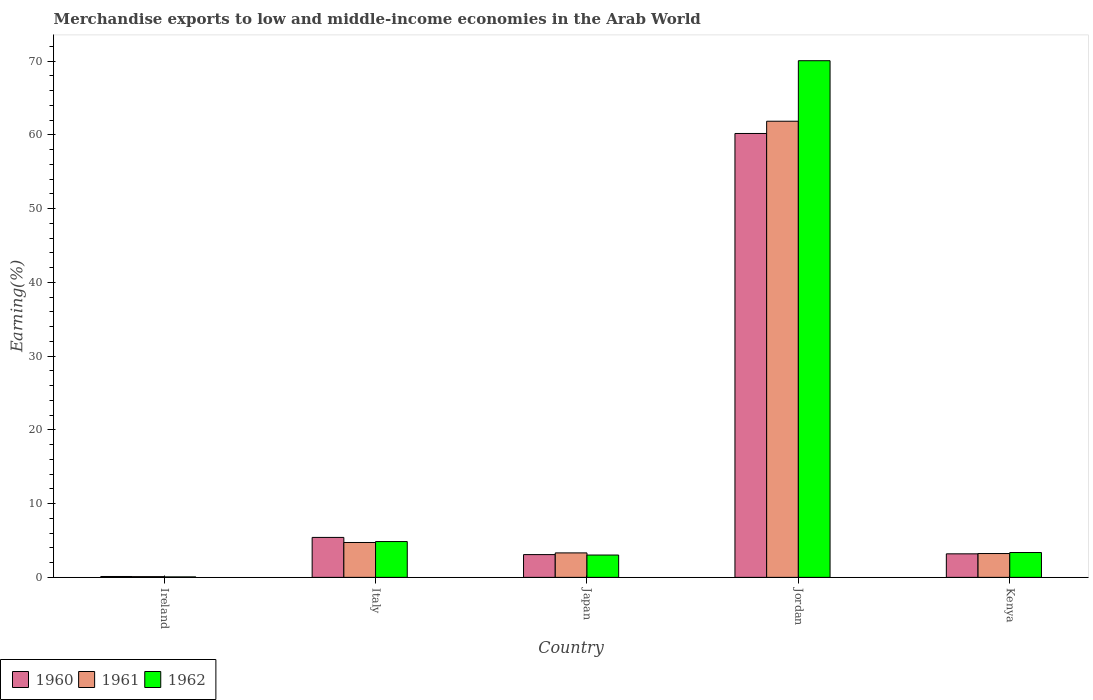How many bars are there on the 4th tick from the left?
Provide a succinct answer. 3. How many bars are there on the 5th tick from the right?
Provide a short and direct response. 3. What is the percentage of amount earned from merchandise exports in 1960 in Ireland?
Make the answer very short. 0.12. Across all countries, what is the maximum percentage of amount earned from merchandise exports in 1961?
Your response must be concise. 61.86. Across all countries, what is the minimum percentage of amount earned from merchandise exports in 1962?
Offer a very short reply. 0.06. In which country was the percentage of amount earned from merchandise exports in 1962 maximum?
Your answer should be compact. Jordan. In which country was the percentage of amount earned from merchandise exports in 1960 minimum?
Provide a short and direct response. Ireland. What is the total percentage of amount earned from merchandise exports in 1960 in the graph?
Your response must be concise. 72.02. What is the difference between the percentage of amount earned from merchandise exports in 1962 in Ireland and that in Kenya?
Offer a very short reply. -3.31. What is the difference between the percentage of amount earned from merchandise exports in 1961 in Kenya and the percentage of amount earned from merchandise exports in 1960 in Jordan?
Offer a very short reply. -56.97. What is the average percentage of amount earned from merchandise exports in 1960 per country?
Your response must be concise. 14.4. What is the difference between the percentage of amount earned from merchandise exports of/in 1962 and percentage of amount earned from merchandise exports of/in 1961 in Jordan?
Offer a very short reply. 8.21. What is the ratio of the percentage of amount earned from merchandise exports in 1962 in Ireland to that in Jordan?
Your response must be concise. 0. Is the percentage of amount earned from merchandise exports in 1960 in Italy less than that in Kenya?
Offer a terse response. No. Is the difference between the percentage of amount earned from merchandise exports in 1962 in Ireland and Kenya greater than the difference between the percentage of amount earned from merchandise exports in 1961 in Ireland and Kenya?
Offer a very short reply. No. What is the difference between the highest and the second highest percentage of amount earned from merchandise exports in 1960?
Give a very brief answer. -57.01. What is the difference between the highest and the lowest percentage of amount earned from merchandise exports in 1960?
Keep it short and to the point. 60.09. In how many countries, is the percentage of amount earned from merchandise exports in 1960 greater than the average percentage of amount earned from merchandise exports in 1960 taken over all countries?
Your answer should be compact. 1. What does the 1st bar from the left in Jordan represents?
Ensure brevity in your answer.  1960. What does the 3rd bar from the right in Italy represents?
Keep it short and to the point. 1960. How many countries are there in the graph?
Your response must be concise. 5. Are the values on the major ticks of Y-axis written in scientific E-notation?
Ensure brevity in your answer.  No. Does the graph contain grids?
Offer a very short reply. No. Where does the legend appear in the graph?
Your response must be concise. Bottom left. What is the title of the graph?
Your answer should be compact. Merchandise exports to low and middle-income economies in the Arab World. Does "1969" appear as one of the legend labels in the graph?
Provide a short and direct response. No. What is the label or title of the Y-axis?
Ensure brevity in your answer.  Earning(%). What is the Earning(%) of 1960 in Ireland?
Offer a very short reply. 0.12. What is the Earning(%) in 1961 in Ireland?
Your response must be concise. 0.1. What is the Earning(%) of 1962 in Ireland?
Provide a short and direct response. 0.06. What is the Earning(%) in 1960 in Italy?
Provide a succinct answer. 5.42. What is the Earning(%) of 1961 in Italy?
Offer a terse response. 4.73. What is the Earning(%) of 1962 in Italy?
Offer a very short reply. 4.86. What is the Earning(%) of 1960 in Japan?
Your response must be concise. 3.09. What is the Earning(%) of 1961 in Japan?
Your answer should be very brief. 3.32. What is the Earning(%) in 1962 in Japan?
Make the answer very short. 3.03. What is the Earning(%) of 1960 in Jordan?
Ensure brevity in your answer.  60.2. What is the Earning(%) in 1961 in Jordan?
Give a very brief answer. 61.86. What is the Earning(%) in 1962 in Jordan?
Keep it short and to the point. 70.07. What is the Earning(%) of 1960 in Kenya?
Keep it short and to the point. 3.19. What is the Earning(%) in 1961 in Kenya?
Offer a terse response. 3.23. What is the Earning(%) in 1962 in Kenya?
Give a very brief answer. 3.37. Across all countries, what is the maximum Earning(%) in 1960?
Keep it short and to the point. 60.2. Across all countries, what is the maximum Earning(%) in 1961?
Make the answer very short. 61.86. Across all countries, what is the maximum Earning(%) of 1962?
Your answer should be very brief. 70.07. Across all countries, what is the minimum Earning(%) of 1960?
Your response must be concise. 0.12. Across all countries, what is the minimum Earning(%) of 1961?
Your answer should be very brief. 0.1. Across all countries, what is the minimum Earning(%) in 1962?
Your answer should be compact. 0.06. What is the total Earning(%) in 1960 in the graph?
Your answer should be very brief. 72.02. What is the total Earning(%) in 1961 in the graph?
Offer a very short reply. 73.24. What is the total Earning(%) of 1962 in the graph?
Ensure brevity in your answer.  81.39. What is the difference between the Earning(%) in 1960 in Ireland and that in Italy?
Keep it short and to the point. -5.3. What is the difference between the Earning(%) in 1961 in Ireland and that in Italy?
Provide a succinct answer. -4.63. What is the difference between the Earning(%) of 1962 in Ireland and that in Italy?
Offer a terse response. -4.79. What is the difference between the Earning(%) in 1960 in Ireland and that in Japan?
Ensure brevity in your answer.  -2.97. What is the difference between the Earning(%) of 1961 in Ireland and that in Japan?
Your response must be concise. -3.22. What is the difference between the Earning(%) in 1962 in Ireland and that in Japan?
Make the answer very short. -2.97. What is the difference between the Earning(%) of 1960 in Ireland and that in Jordan?
Your response must be concise. -60.09. What is the difference between the Earning(%) in 1961 in Ireland and that in Jordan?
Make the answer very short. -61.77. What is the difference between the Earning(%) in 1962 in Ireland and that in Jordan?
Provide a succinct answer. -70.01. What is the difference between the Earning(%) in 1960 in Ireland and that in Kenya?
Offer a very short reply. -3.07. What is the difference between the Earning(%) in 1961 in Ireland and that in Kenya?
Your response must be concise. -3.13. What is the difference between the Earning(%) in 1962 in Ireland and that in Kenya?
Give a very brief answer. -3.31. What is the difference between the Earning(%) of 1960 in Italy and that in Japan?
Your answer should be very brief. 2.33. What is the difference between the Earning(%) of 1961 in Italy and that in Japan?
Give a very brief answer. 1.41. What is the difference between the Earning(%) in 1962 in Italy and that in Japan?
Provide a short and direct response. 1.83. What is the difference between the Earning(%) of 1960 in Italy and that in Jordan?
Keep it short and to the point. -54.79. What is the difference between the Earning(%) in 1961 in Italy and that in Jordan?
Make the answer very short. -57.14. What is the difference between the Earning(%) of 1962 in Italy and that in Jordan?
Make the answer very short. -65.22. What is the difference between the Earning(%) in 1960 in Italy and that in Kenya?
Your response must be concise. 2.23. What is the difference between the Earning(%) in 1961 in Italy and that in Kenya?
Make the answer very short. 1.5. What is the difference between the Earning(%) of 1962 in Italy and that in Kenya?
Keep it short and to the point. 1.49. What is the difference between the Earning(%) in 1960 in Japan and that in Jordan?
Your answer should be compact. -57.12. What is the difference between the Earning(%) in 1961 in Japan and that in Jordan?
Your answer should be very brief. -58.55. What is the difference between the Earning(%) in 1962 in Japan and that in Jordan?
Ensure brevity in your answer.  -67.05. What is the difference between the Earning(%) in 1960 in Japan and that in Kenya?
Keep it short and to the point. -0.1. What is the difference between the Earning(%) in 1961 in Japan and that in Kenya?
Your response must be concise. 0.09. What is the difference between the Earning(%) of 1962 in Japan and that in Kenya?
Keep it short and to the point. -0.34. What is the difference between the Earning(%) in 1960 in Jordan and that in Kenya?
Your response must be concise. 57.01. What is the difference between the Earning(%) in 1961 in Jordan and that in Kenya?
Ensure brevity in your answer.  58.63. What is the difference between the Earning(%) in 1962 in Jordan and that in Kenya?
Provide a succinct answer. 66.7. What is the difference between the Earning(%) of 1960 in Ireland and the Earning(%) of 1961 in Italy?
Offer a terse response. -4.61. What is the difference between the Earning(%) of 1960 in Ireland and the Earning(%) of 1962 in Italy?
Keep it short and to the point. -4.74. What is the difference between the Earning(%) in 1961 in Ireland and the Earning(%) in 1962 in Italy?
Give a very brief answer. -4.76. What is the difference between the Earning(%) in 1960 in Ireland and the Earning(%) in 1961 in Japan?
Your answer should be compact. -3.2. What is the difference between the Earning(%) in 1960 in Ireland and the Earning(%) in 1962 in Japan?
Your response must be concise. -2.91. What is the difference between the Earning(%) in 1961 in Ireland and the Earning(%) in 1962 in Japan?
Your response must be concise. -2.93. What is the difference between the Earning(%) of 1960 in Ireland and the Earning(%) of 1961 in Jordan?
Offer a very short reply. -61.75. What is the difference between the Earning(%) of 1960 in Ireland and the Earning(%) of 1962 in Jordan?
Make the answer very short. -69.96. What is the difference between the Earning(%) of 1961 in Ireland and the Earning(%) of 1962 in Jordan?
Keep it short and to the point. -69.97. What is the difference between the Earning(%) of 1960 in Ireland and the Earning(%) of 1961 in Kenya?
Provide a short and direct response. -3.11. What is the difference between the Earning(%) of 1960 in Ireland and the Earning(%) of 1962 in Kenya?
Your response must be concise. -3.25. What is the difference between the Earning(%) of 1961 in Ireland and the Earning(%) of 1962 in Kenya?
Ensure brevity in your answer.  -3.27. What is the difference between the Earning(%) of 1960 in Italy and the Earning(%) of 1961 in Japan?
Make the answer very short. 2.1. What is the difference between the Earning(%) in 1960 in Italy and the Earning(%) in 1962 in Japan?
Ensure brevity in your answer.  2.39. What is the difference between the Earning(%) in 1961 in Italy and the Earning(%) in 1962 in Japan?
Offer a terse response. 1.7. What is the difference between the Earning(%) in 1960 in Italy and the Earning(%) in 1961 in Jordan?
Make the answer very short. -56.45. What is the difference between the Earning(%) of 1960 in Italy and the Earning(%) of 1962 in Jordan?
Offer a terse response. -64.65. What is the difference between the Earning(%) of 1961 in Italy and the Earning(%) of 1962 in Jordan?
Give a very brief answer. -65.34. What is the difference between the Earning(%) in 1960 in Italy and the Earning(%) in 1961 in Kenya?
Make the answer very short. 2.19. What is the difference between the Earning(%) in 1960 in Italy and the Earning(%) in 1962 in Kenya?
Offer a very short reply. 2.05. What is the difference between the Earning(%) of 1961 in Italy and the Earning(%) of 1962 in Kenya?
Offer a very short reply. 1.36. What is the difference between the Earning(%) in 1960 in Japan and the Earning(%) in 1961 in Jordan?
Provide a short and direct response. -58.78. What is the difference between the Earning(%) of 1960 in Japan and the Earning(%) of 1962 in Jordan?
Keep it short and to the point. -66.99. What is the difference between the Earning(%) in 1961 in Japan and the Earning(%) in 1962 in Jordan?
Provide a succinct answer. -66.75. What is the difference between the Earning(%) of 1960 in Japan and the Earning(%) of 1961 in Kenya?
Ensure brevity in your answer.  -0.14. What is the difference between the Earning(%) in 1960 in Japan and the Earning(%) in 1962 in Kenya?
Your answer should be compact. -0.28. What is the difference between the Earning(%) of 1961 in Japan and the Earning(%) of 1962 in Kenya?
Your answer should be very brief. -0.05. What is the difference between the Earning(%) in 1960 in Jordan and the Earning(%) in 1961 in Kenya?
Your answer should be very brief. 56.97. What is the difference between the Earning(%) in 1960 in Jordan and the Earning(%) in 1962 in Kenya?
Give a very brief answer. 56.84. What is the difference between the Earning(%) of 1961 in Jordan and the Earning(%) of 1962 in Kenya?
Your answer should be compact. 58.5. What is the average Earning(%) in 1960 per country?
Make the answer very short. 14.4. What is the average Earning(%) in 1961 per country?
Provide a succinct answer. 14.65. What is the average Earning(%) in 1962 per country?
Make the answer very short. 16.28. What is the difference between the Earning(%) of 1960 and Earning(%) of 1961 in Ireland?
Your answer should be very brief. 0.02. What is the difference between the Earning(%) in 1960 and Earning(%) in 1962 in Ireland?
Provide a succinct answer. 0.06. What is the difference between the Earning(%) in 1961 and Earning(%) in 1962 in Ireland?
Your response must be concise. 0.04. What is the difference between the Earning(%) in 1960 and Earning(%) in 1961 in Italy?
Give a very brief answer. 0.69. What is the difference between the Earning(%) in 1960 and Earning(%) in 1962 in Italy?
Make the answer very short. 0.56. What is the difference between the Earning(%) of 1961 and Earning(%) of 1962 in Italy?
Provide a short and direct response. -0.13. What is the difference between the Earning(%) of 1960 and Earning(%) of 1961 in Japan?
Offer a terse response. -0.23. What is the difference between the Earning(%) in 1960 and Earning(%) in 1962 in Japan?
Ensure brevity in your answer.  0.06. What is the difference between the Earning(%) in 1961 and Earning(%) in 1962 in Japan?
Your answer should be very brief. 0.29. What is the difference between the Earning(%) of 1960 and Earning(%) of 1961 in Jordan?
Ensure brevity in your answer.  -1.66. What is the difference between the Earning(%) in 1960 and Earning(%) in 1962 in Jordan?
Your answer should be compact. -9.87. What is the difference between the Earning(%) of 1961 and Earning(%) of 1962 in Jordan?
Keep it short and to the point. -8.21. What is the difference between the Earning(%) of 1960 and Earning(%) of 1961 in Kenya?
Offer a terse response. -0.04. What is the difference between the Earning(%) of 1960 and Earning(%) of 1962 in Kenya?
Provide a succinct answer. -0.18. What is the difference between the Earning(%) of 1961 and Earning(%) of 1962 in Kenya?
Offer a very short reply. -0.14. What is the ratio of the Earning(%) in 1960 in Ireland to that in Italy?
Provide a succinct answer. 0.02. What is the ratio of the Earning(%) in 1961 in Ireland to that in Italy?
Offer a very short reply. 0.02. What is the ratio of the Earning(%) of 1962 in Ireland to that in Italy?
Provide a succinct answer. 0.01. What is the ratio of the Earning(%) in 1960 in Ireland to that in Japan?
Provide a short and direct response. 0.04. What is the ratio of the Earning(%) of 1961 in Ireland to that in Japan?
Keep it short and to the point. 0.03. What is the ratio of the Earning(%) of 1962 in Ireland to that in Japan?
Make the answer very short. 0.02. What is the ratio of the Earning(%) in 1960 in Ireland to that in Jordan?
Provide a succinct answer. 0. What is the ratio of the Earning(%) in 1961 in Ireland to that in Jordan?
Ensure brevity in your answer.  0. What is the ratio of the Earning(%) in 1962 in Ireland to that in Jordan?
Provide a succinct answer. 0. What is the ratio of the Earning(%) of 1960 in Ireland to that in Kenya?
Keep it short and to the point. 0.04. What is the ratio of the Earning(%) in 1961 in Ireland to that in Kenya?
Your response must be concise. 0.03. What is the ratio of the Earning(%) in 1962 in Ireland to that in Kenya?
Offer a very short reply. 0.02. What is the ratio of the Earning(%) of 1960 in Italy to that in Japan?
Offer a very short reply. 1.75. What is the ratio of the Earning(%) of 1961 in Italy to that in Japan?
Offer a very short reply. 1.43. What is the ratio of the Earning(%) in 1962 in Italy to that in Japan?
Offer a very short reply. 1.6. What is the ratio of the Earning(%) of 1960 in Italy to that in Jordan?
Your answer should be compact. 0.09. What is the ratio of the Earning(%) in 1961 in Italy to that in Jordan?
Keep it short and to the point. 0.08. What is the ratio of the Earning(%) of 1962 in Italy to that in Jordan?
Make the answer very short. 0.07. What is the ratio of the Earning(%) in 1960 in Italy to that in Kenya?
Offer a very short reply. 1.7. What is the ratio of the Earning(%) of 1961 in Italy to that in Kenya?
Give a very brief answer. 1.46. What is the ratio of the Earning(%) in 1962 in Italy to that in Kenya?
Keep it short and to the point. 1.44. What is the ratio of the Earning(%) in 1960 in Japan to that in Jordan?
Provide a short and direct response. 0.05. What is the ratio of the Earning(%) in 1961 in Japan to that in Jordan?
Offer a very short reply. 0.05. What is the ratio of the Earning(%) in 1962 in Japan to that in Jordan?
Your response must be concise. 0.04. What is the ratio of the Earning(%) of 1960 in Japan to that in Kenya?
Your response must be concise. 0.97. What is the ratio of the Earning(%) of 1962 in Japan to that in Kenya?
Your answer should be very brief. 0.9. What is the ratio of the Earning(%) in 1960 in Jordan to that in Kenya?
Your answer should be compact. 18.87. What is the ratio of the Earning(%) of 1961 in Jordan to that in Kenya?
Ensure brevity in your answer.  19.14. What is the ratio of the Earning(%) in 1962 in Jordan to that in Kenya?
Your answer should be very brief. 20.8. What is the difference between the highest and the second highest Earning(%) in 1960?
Ensure brevity in your answer.  54.79. What is the difference between the highest and the second highest Earning(%) of 1961?
Keep it short and to the point. 57.14. What is the difference between the highest and the second highest Earning(%) in 1962?
Keep it short and to the point. 65.22. What is the difference between the highest and the lowest Earning(%) of 1960?
Offer a very short reply. 60.09. What is the difference between the highest and the lowest Earning(%) of 1961?
Your response must be concise. 61.77. What is the difference between the highest and the lowest Earning(%) in 1962?
Provide a short and direct response. 70.01. 